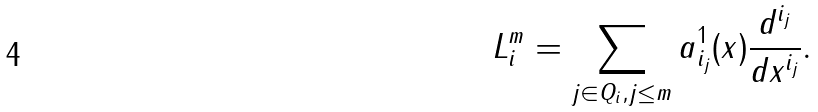<formula> <loc_0><loc_0><loc_500><loc_500>L _ { i } ^ { m } = \sum _ { j \in Q _ { i } , j \leq m } a ^ { 1 } _ { i _ { j } } ( x ) \frac { d ^ { i _ { j } } } { d x ^ { i _ { j } } } .</formula> 